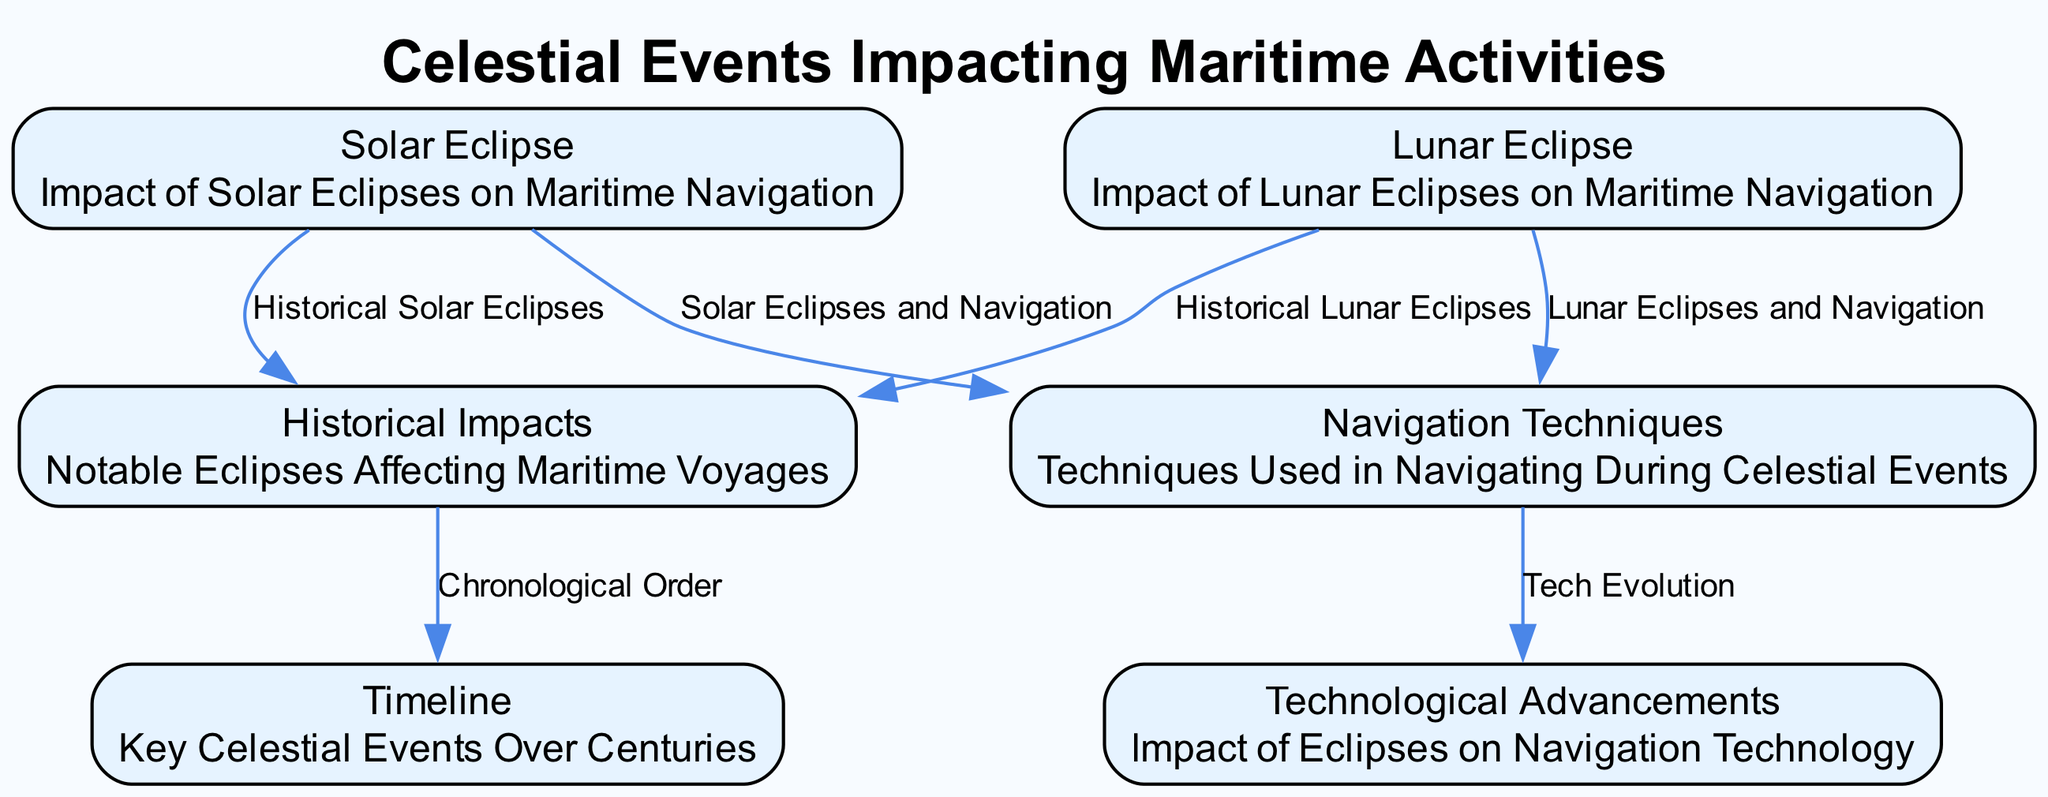What are the main types of celestial events shown in the diagram? The diagram displays solar eclipses and lunar eclipses as the main celestial events affecting maritime activities. Both types are indicated in the nodes labeled "Solar Eclipse" and "Lunar Eclipse."
Answer: Solar eclipse, lunar eclipse How many historical impacts are noted in the diagram? The "Historical Impacts" node implies that multiple events are documented, though the exact count isn't specified. Based on the node's description, we can infer it points to several notable eclipses.
Answer: Multiple What is the relationship between solar eclipses and navigation techniques? The diagram indicates a direct relationship, with an edge showing "Solar Eclipses and Navigation." This suggests that specific navigation techniques are influenced by solar eclipses.
Answer: Techniques change What does "Tech Evolution" signify in the context of the diagram? "Tech Evolution" describes the relationship between navigation techniques and technological advancements, indicating that changes in navigation practices have led to advancements in navigation technology.
Answer: Navigation technology advancement Which celestial event is linked to historical maritime voyages? Both solar eclipses and lunar eclipses are linked to historical maritime voyages, as indicated by edges connecting each of these events to the "Historical Impacts" node.
Answer: Solar and lunar eclipses What does the "Timeline" node represent? The "Timeline" node represents key celestial events over the centuries, suggesting that it organizes information regarding when specific events occurred in relation to each other historically.
Answer: Key celestial events How does lunar eclipses impact navigation? The diagram connects lunar eclipses to navigation, indicating that they influence the way mariners adjust their navigation strategies during such events.
Answer: Navigation affected What type of diagram is this? The diagram is classified as an Astronomy Diagram, as it visually represents celestial events and their impact on maritime activities.
Answer: Astronomy Diagram How many edges connect to the "Historical Impacts" node? There are two edges connecting to the "Historical Impacts" node, one from the "Solar Eclipse" and another from the "Lunar Eclipse."
Answer: Two edges 